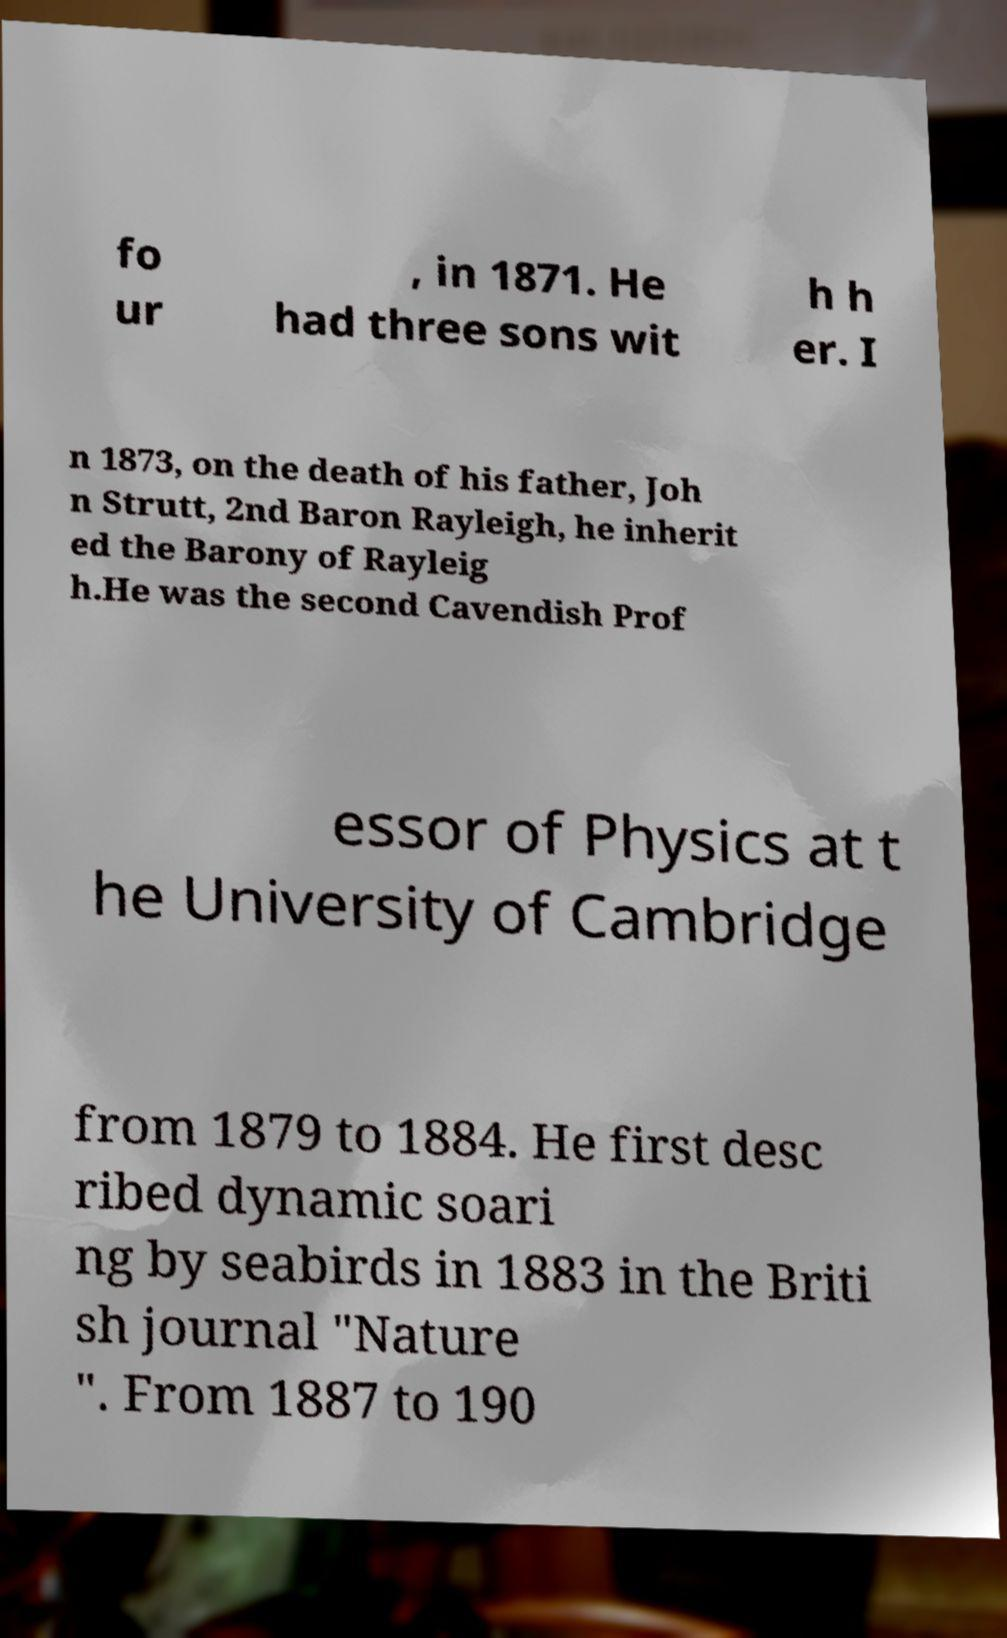I need the written content from this picture converted into text. Can you do that? fo ur , in 1871. He had three sons wit h h er. I n 1873, on the death of his father, Joh n Strutt, 2nd Baron Rayleigh, he inherit ed the Barony of Rayleig h.He was the second Cavendish Prof essor of Physics at t he University of Cambridge from 1879 to 1884. He first desc ribed dynamic soari ng by seabirds in 1883 in the Briti sh journal "Nature ". From 1887 to 190 